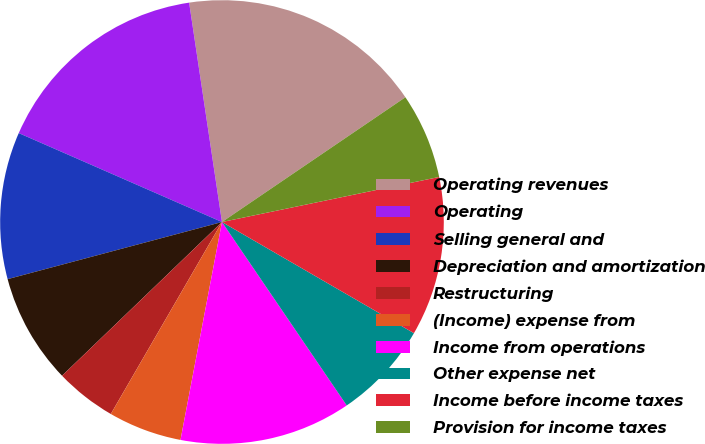Convert chart to OTSL. <chart><loc_0><loc_0><loc_500><loc_500><pie_chart><fcel>Operating revenues<fcel>Operating<fcel>Selling general and<fcel>Depreciation and amortization<fcel>Restructuring<fcel>(Income) expense from<fcel>Income from operations<fcel>Other expense net<fcel>Income before income taxes<fcel>Provision for income taxes<nl><fcel>17.86%<fcel>16.07%<fcel>10.71%<fcel>8.04%<fcel>4.46%<fcel>5.36%<fcel>12.5%<fcel>7.14%<fcel>11.61%<fcel>6.25%<nl></chart> 